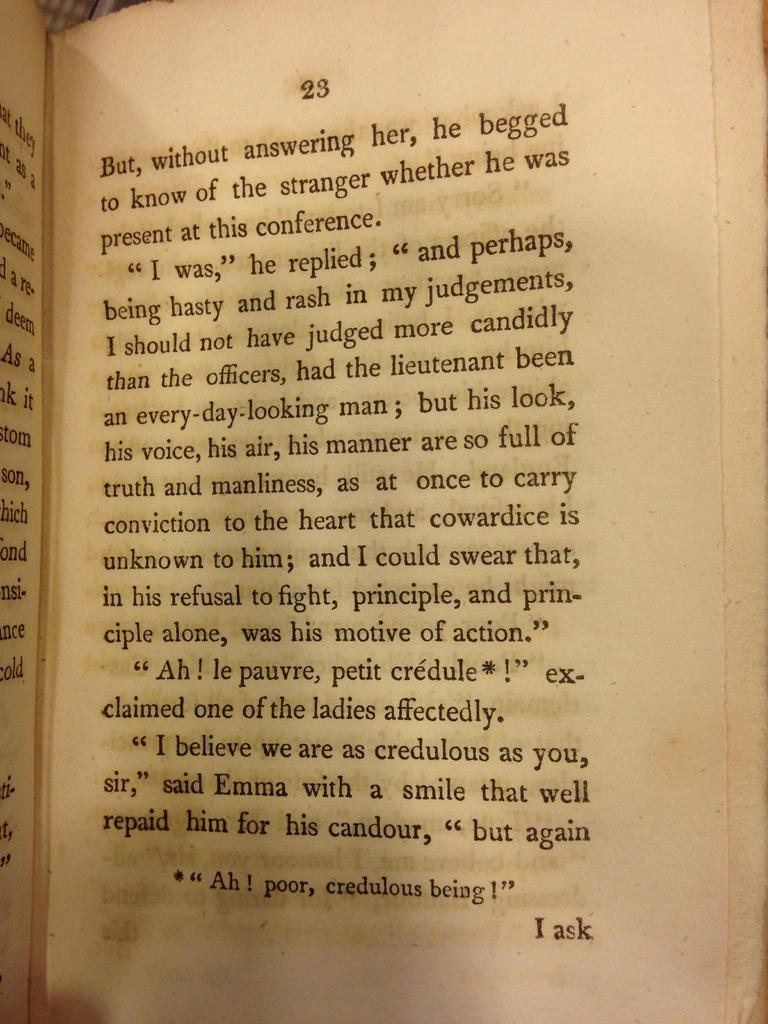<image>
Render a clear and concise summary of the photo. a book open to page 23 with the last words on it being 'i ask' 